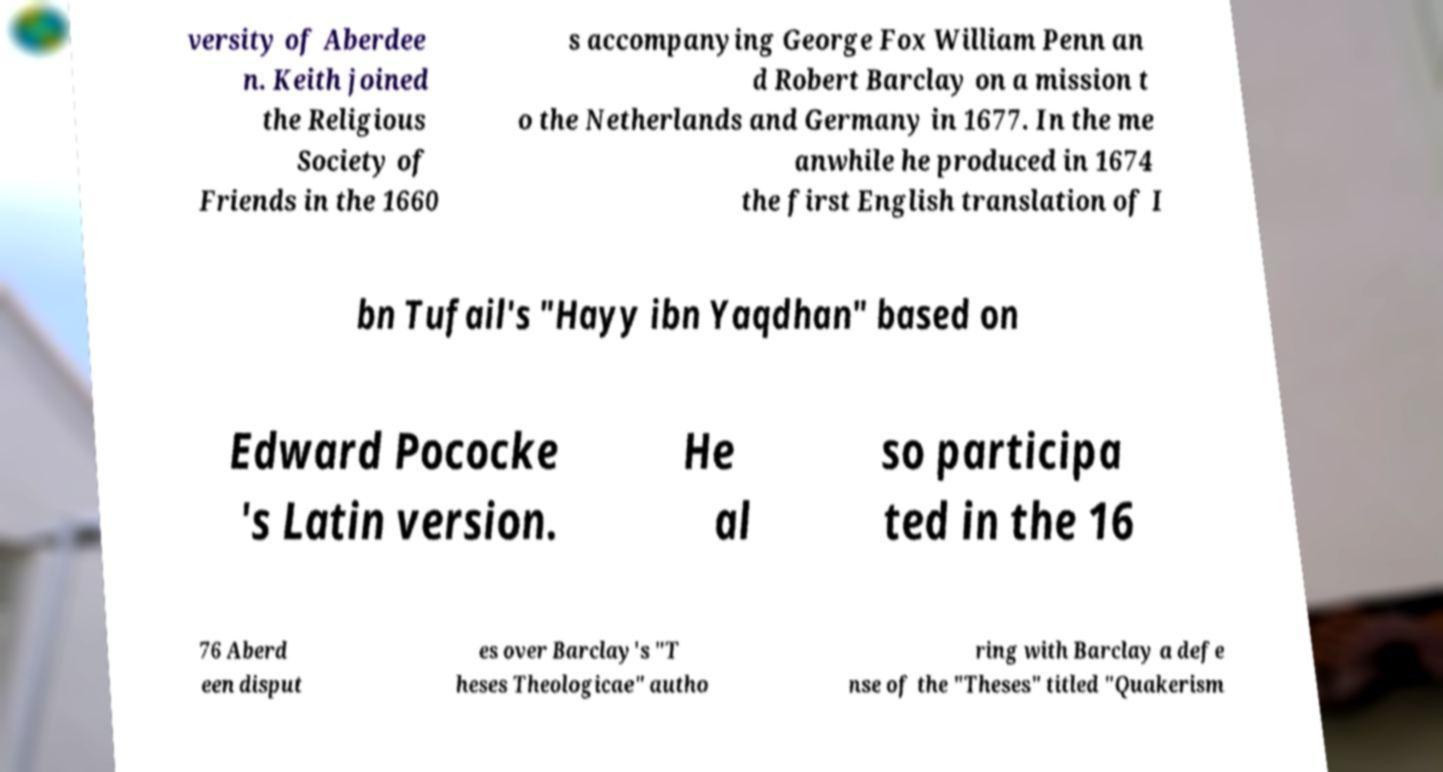There's text embedded in this image that I need extracted. Can you transcribe it verbatim? versity of Aberdee n. Keith joined the Religious Society of Friends in the 1660 s accompanying George Fox William Penn an d Robert Barclay on a mission t o the Netherlands and Germany in 1677. In the me anwhile he produced in 1674 the first English translation of I bn Tufail's "Hayy ibn Yaqdhan" based on Edward Pococke 's Latin version. He al so participa ted in the 16 76 Aberd een disput es over Barclay's "T heses Theologicae" autho ring with Barclay a defe nse of the "Theses" titled "Quakerism 